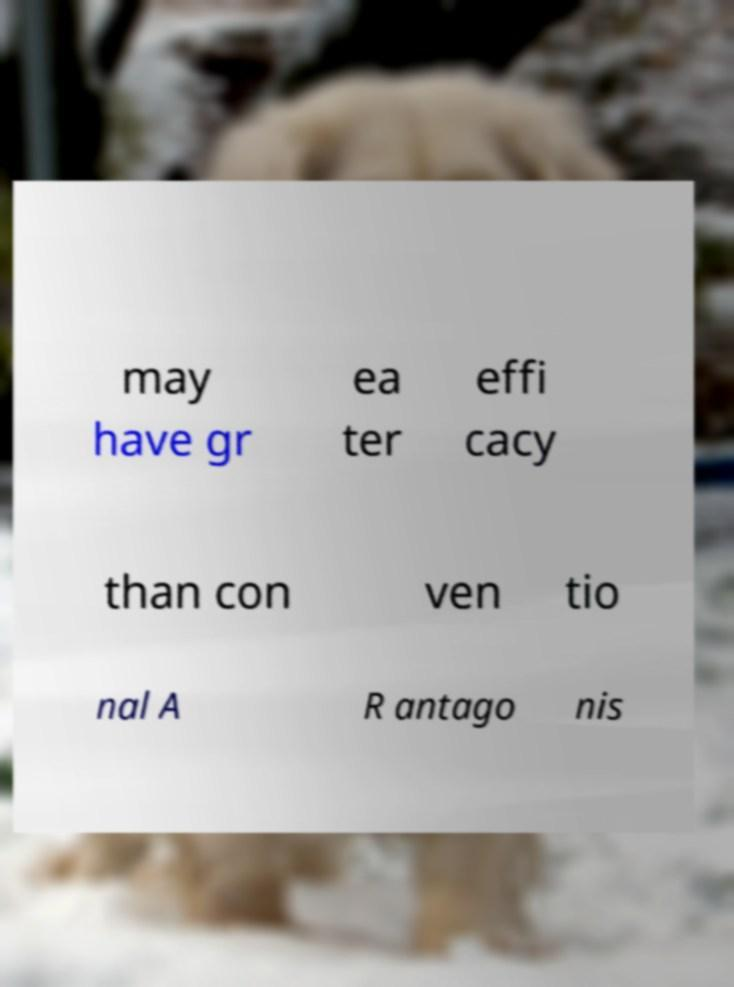For documentation purposes, I need the text within this image transcribed. Could you provide that? may have gr ea ter effi cacy than con ven tio nal A R antago nis 